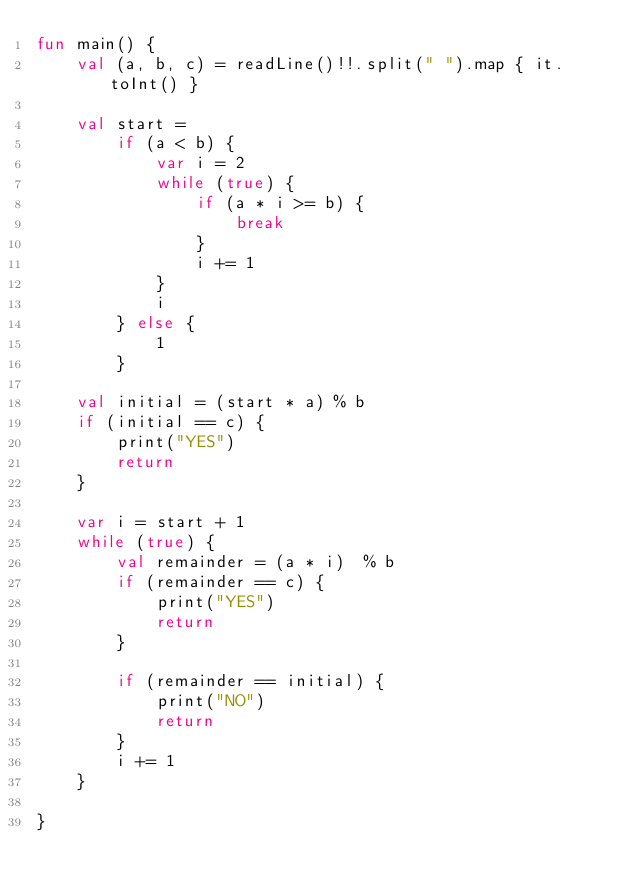Convert code to text. <code><loc_0><loc_0><loc_500><loc_500><_Kotlin_>fun main() {
    val (a, b, c) = readLine()!!.split(" ").map { it.toInt() }

    val start =
        if (a < b) {
            var i = 2
            while (true) {
                if (a * i >= b) {
                    break
                }
                i += 1
            }
            i
        } else {
            1
        }

    val initial = (start * a) % b
    if (initial == c) {
        print("YES")
        return
    }

    var i = start + 1
    while (true) {
        val remainder = (a * i)  % b
        if (remainder == c) {
            print("YES")
            return
        }

        if (remainder == initial) {
            print("NO")
            return
        }
        i += 1
    }

}
</code> 